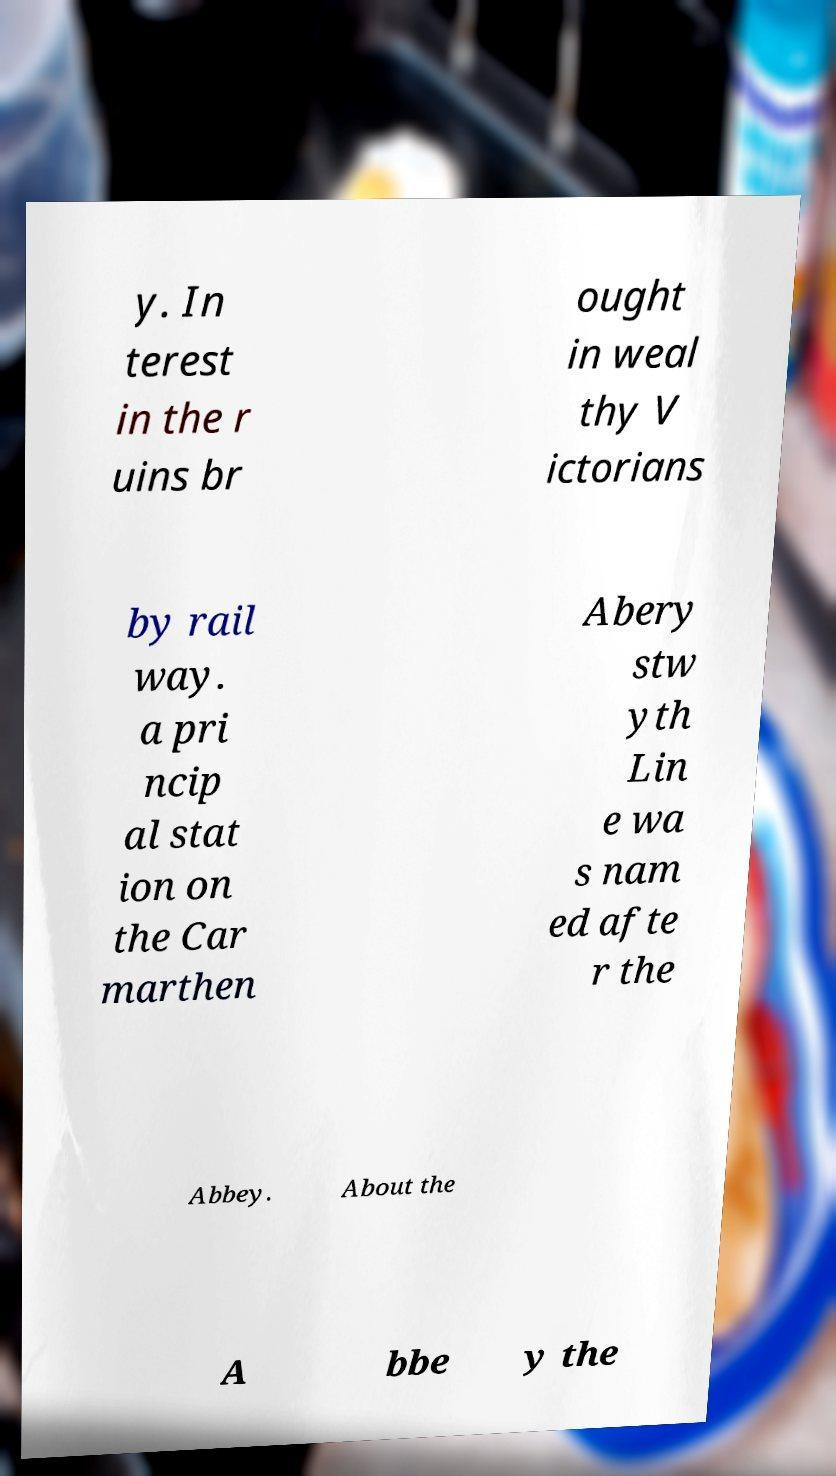Can you read and provide the text displayed in the image?This photo seems to have some interesting text. Can you extract and type it out for me? y. In terest in the r uins br ought in weal thy V ictorians by rail way. a pri ncip al stat ion on the Car marthen Abery stw yth Lin e wa s nam ed afte r the Abbey. About the A bbe y the 